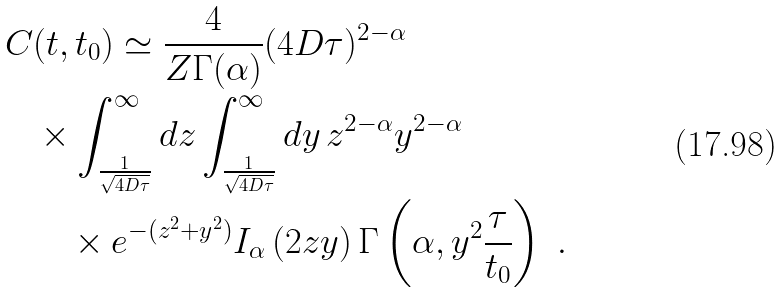Convert formula to latex. <formula><loc_0><loc_0><loc_500><loc_500>C & ( t , t _ { 0 } ) \simeq \frac { 4 } { Z \Gamma ( \alpha ) } ( 4 D \tau ) ^ { 2 - \alpha } \\ & \times \int _ { \frac { 1 } { \sqrt { 4 D \tau } } } ^ { \infty } d z \int _ { \frac { 1 } { \sqrt { 4 D \tau } } } ^ { \infty } d y \, z ^ { 2 - \alpha } y ^ { 2 - \alpha } \\ & \quad \times e ^ { - ( z ^ { 2 } + y ^ { 2 } ) } I _ { \alpha } \left ( 2 z y \right ) \Gamma \left ( \alpha , y ^ { 2 } \frac { \tau } { t _ { 0 } } \right ) \ .</formula> 